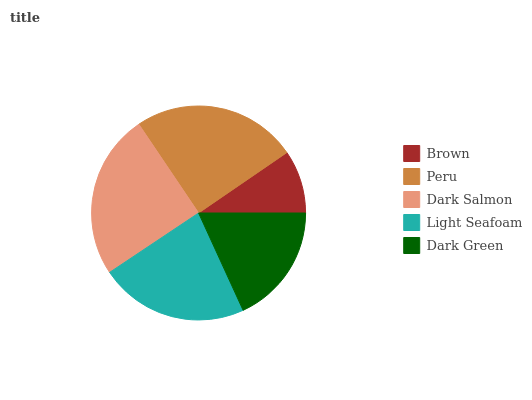Is Brown the minimum?
Answer yes or no. Yes. Is Dark Salmon the maximum?
Answer yes or no. Yes. Is Peru the minimum?
Answer yes or no. No. Is Peru the maximum?
Answer yes or no. No. Is Peru greater than Brown?
Answer yes or no. Yes. Is Brown less than Peru?
Answer yes or no. Yes. Is Brown greater than Peru?
Answer yes or no. No. Is Peru less than Brown?
Answer yes or no. No. Is Light Seafoam the high median?
Answer yes or no. Yes. Is Light Seafoam the low median?
Answer yes or no. Yes. Is Peru the high median?
Answer yes or no. No. Is Dark Salmon the low median?
Answer yes or no. No. 